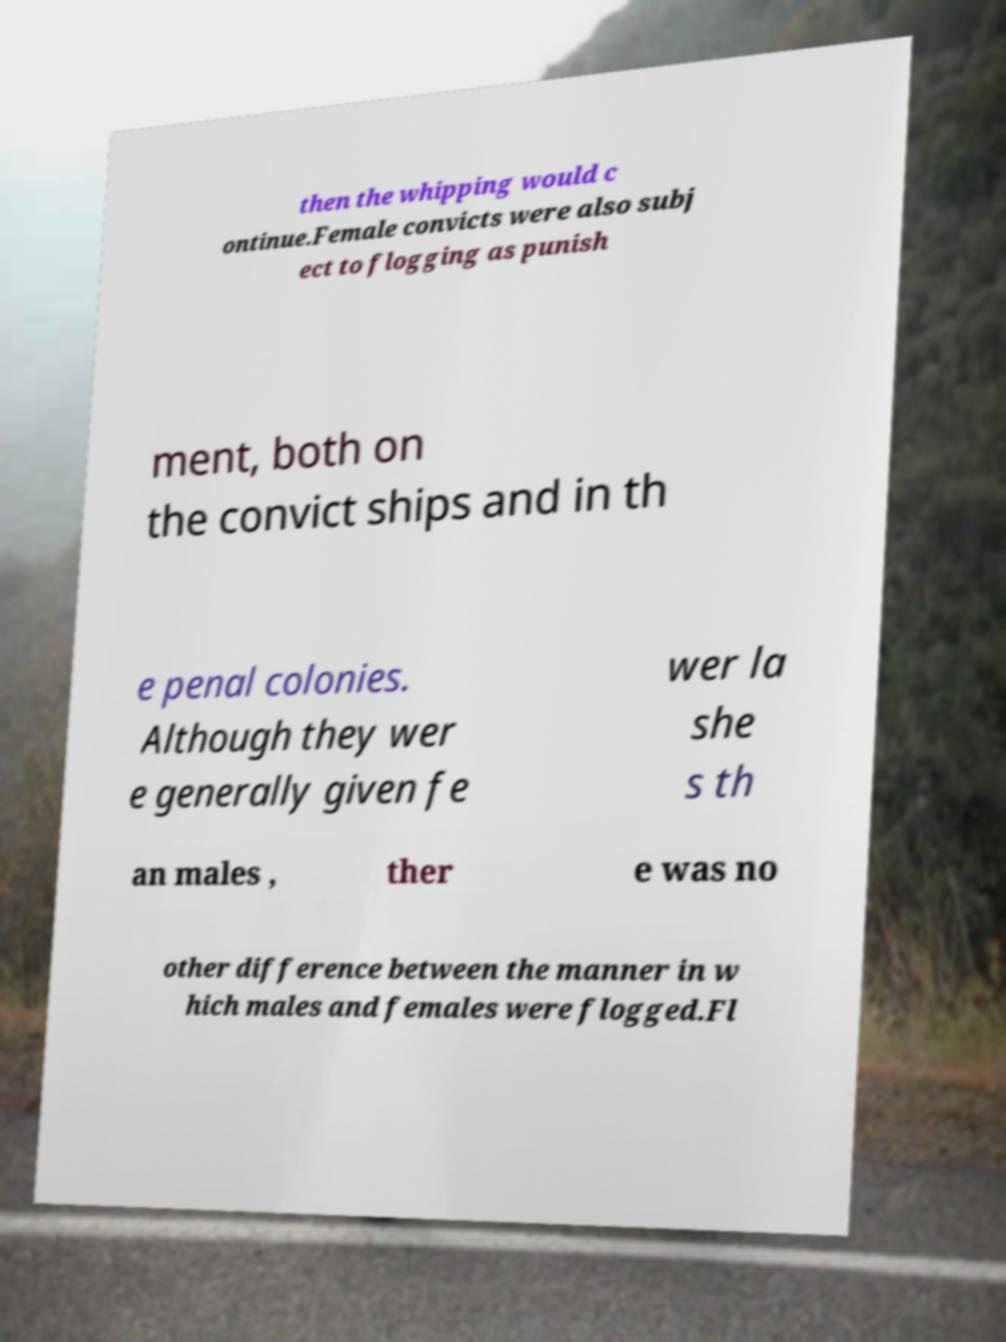Can you accurately transcribe the text from the provided image for me? then the whipping would c ontinue.Female convicts were also subj ect to flogging as punish ment, both on the convict ships and in th e penal colonies. Although they wer e generally given fe wer la she s th an males , ther e was no other difference between the manner in w hich males and females were flogged.Fl 